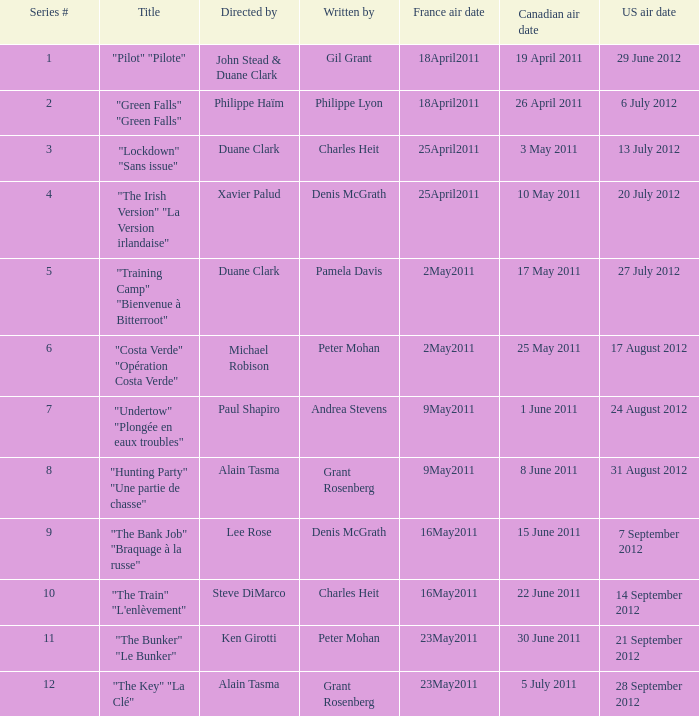What is the canadian broadcast date when the us broadcast date is 24 august 2012? 1 June 2011. 